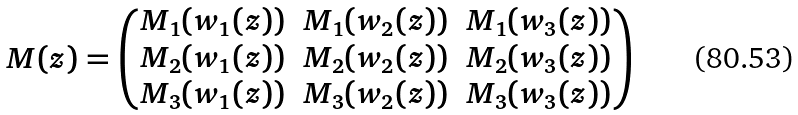Convert formula to latex. <formula><loc_0><loc_0><loc_500><loc_500>M ( z ) = \begin{pmatrix} M _ { 1 } ( w _ { 1 } ( z ) ) & M _ { 1 } ( w _ { 2 } ( z ) ) & M _ { 1 } ( w _ { 3 } ( z ) ) \\ M _ { 2 } ( w _ { 1 } ( z ) ) & M _ { 2 } ( w _ { 2 } ( z ) ) & M _ { 2 } ( w _ { 3 } ( z ) ) \\ M _ { 3 } ( w _ { 1 } ( z ) ) & M _ { 3 } ( w _ { 2 } ( z ) ) & M _ { 3 } ( w _ { 3 } ( z ) ) \end{pmatrix}</formula> 